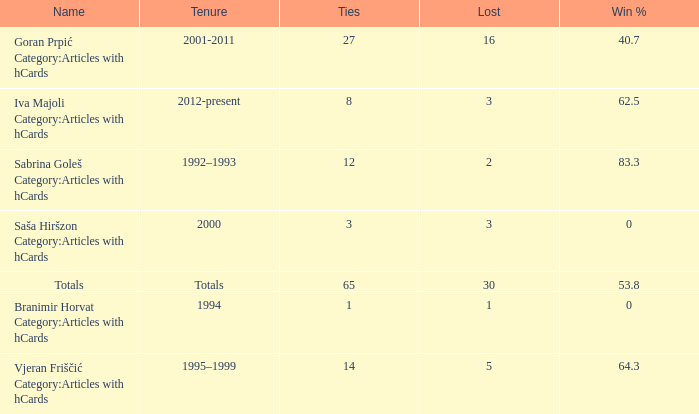I want the total number of ties for win % more than 0 and tenure of 2001-2011 with lost more than 16 0.0. 